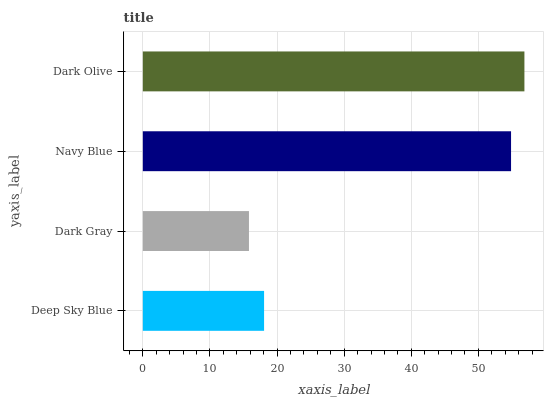Is Dark Gray the minimum?
Answer yes or no. Yes. Is Dark Olive the maximum?
Answer yes or no. Yes. Is Navy Blue the minimum?
Answer yes or no. No. Is Navy Blue the maximum?
Answer yes or no. No. Is Navy Blue greater than Dark Gray?
Answer yes or no. Yes. Is Dark Gray less than Navy Blue?
Answer yes or no. Yes. Is Dark Gray greater than Navy Blue?
Answer yes or no. No. Is Navy Blue less than Dark Gray?
Answer yes or no. No. Is Navy Blue the high median?
Answer yes or no. Yes. Is Deep Sky Blue the low median?
Answer yes or no. Yes. Is Deep Sky Blue the high median?
Answer yes or no. No. Is Dark Gray the low median?
Answer yes or no. No. 